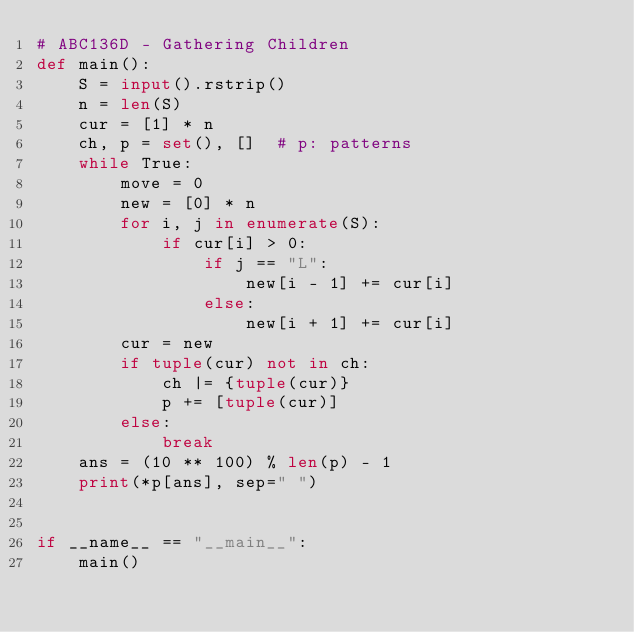<code> <loc_0><loc_0><loc_500><loc_500><_Python_># ABC136D - Gathering Children
def main():
    S = input().rstrip()
    n = len(S)
    cur = [1] * n
    ch, p = set(), []  # p: patterns
    while True:
        move = 0
        new = [0] * n
        for i, j in enumerate(S):
            if cur[i] > 0:
                if j == "L":
                    new[i - 1] += cur[i]
                else:
                    new[i + 1] += cur[i]
        cur = new
        if tuple(cur) not in ch:
            ch |= {tuple(cur)}
            p += [tuple(cur)]
        else:
            break
    ans = (10 ** 100) % len(p) - 1
    print(*p[ans], sep=" ")


if __name__ == "__main__":
    main()</code> 